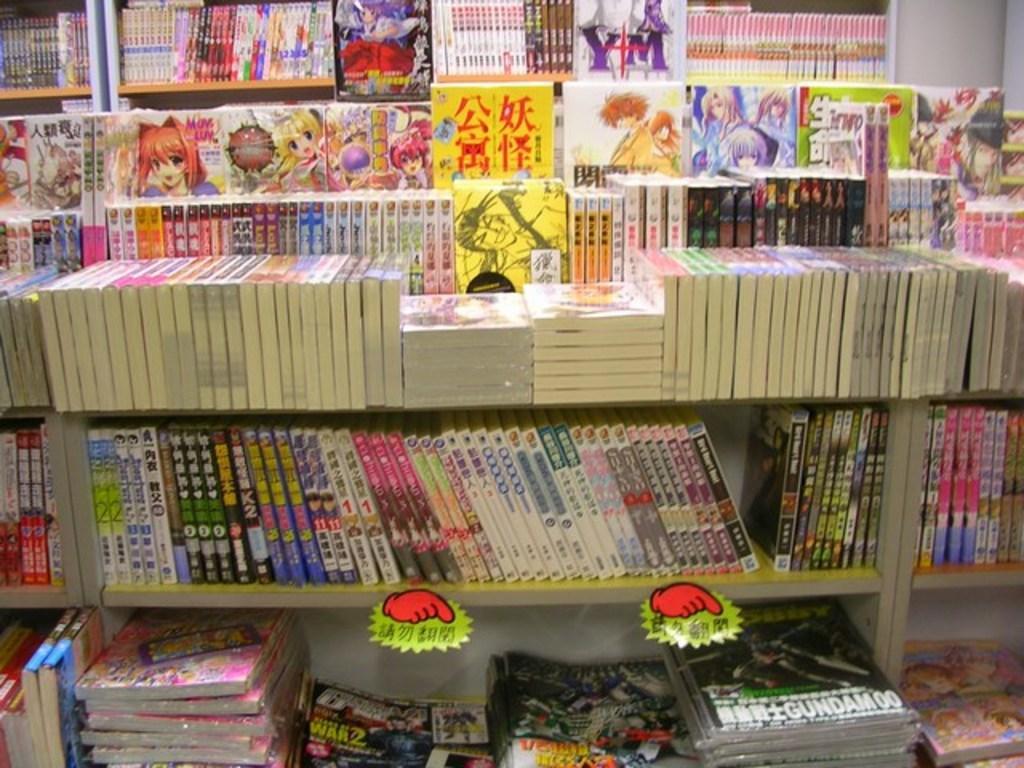Could you give a brief overview of what you see in this image? In this image we can see different types of books are arranged in racks. 